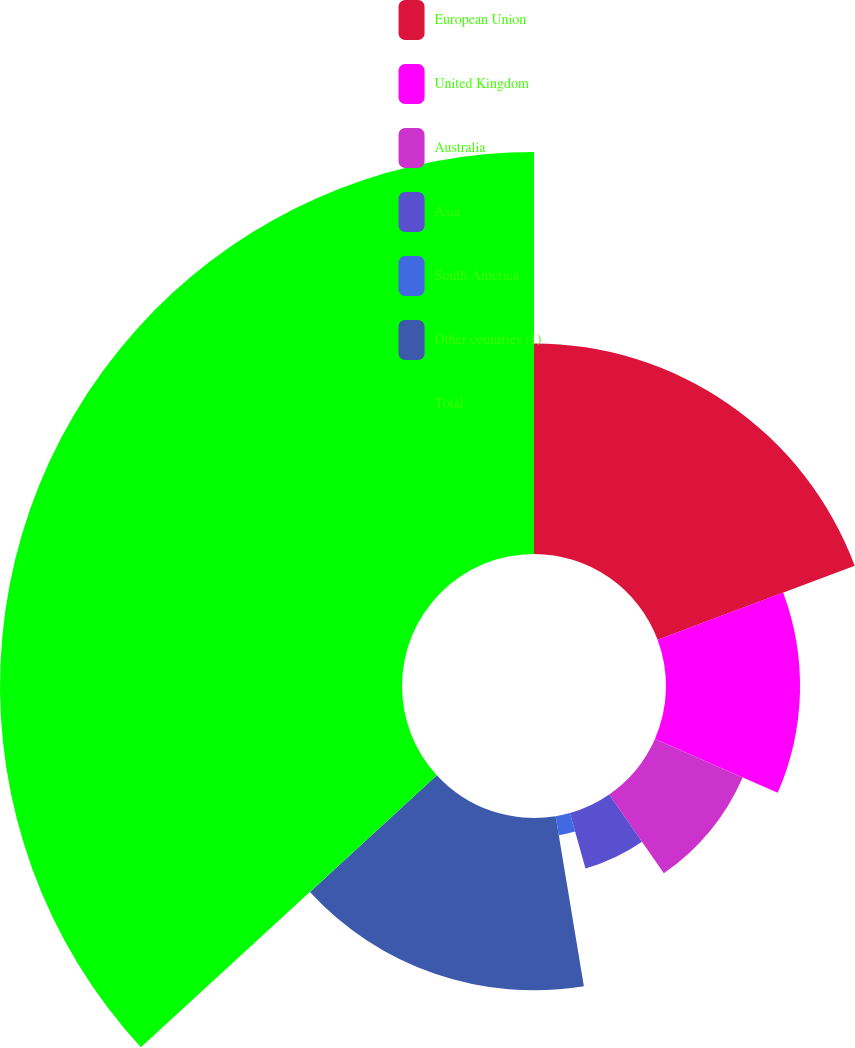<chart> <loc_0><loc_0><loc_500><loc_500><pie_chart><fcel>European Union<fcel>United Kingdom<fcel>Australia<fcel>Asia<fcel>South America<fcel>Other countries (1)<fcel>Total<nl><fcel>19.29%<fcel>12.28%<fcel>8.78%<fcel>5.27%<fcel>1.76%<fcel>15.79%<fcel>36.83%<nl></chart> 